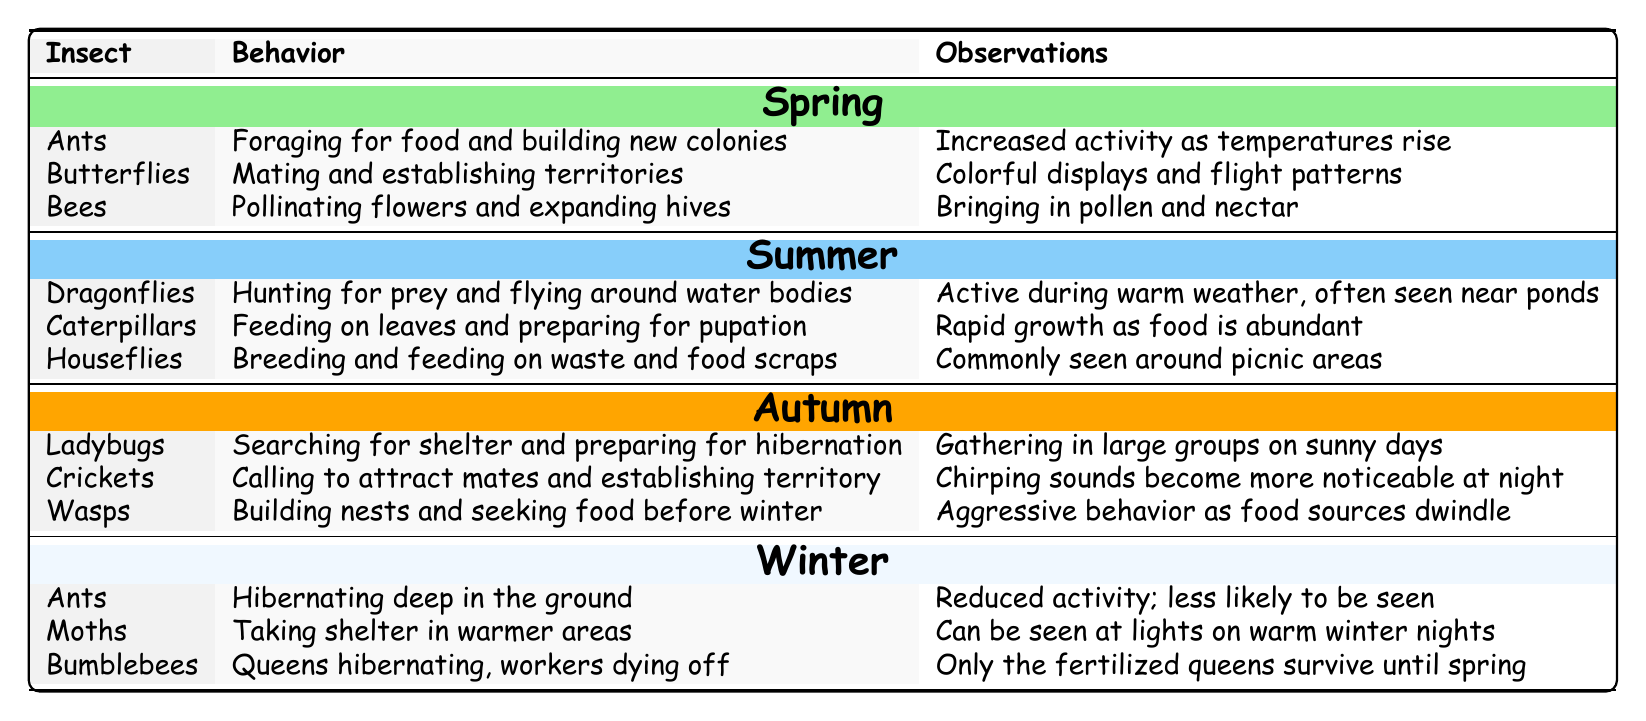What is the behavior of Ladybugs in Autumn? According to the table, Ladybugs are searching for shelter and preparing for hibernation during Autumn.
Answer: Searching for shelter and preparing for hibernation Which insects hibernate during Winter? The table lists ants, moths, and bumblebees as insects that hibernate during Winter.
Answer: Ants, moths, and bumblebees In which season are Dragonflies most active? The table indicates that Dragonflies are active during Summer, where they hunt for prey and frequently fly around water bodies.
Answer: Summer How many insects are listed for Spring? The table shows that there are three insects—Ants, Butterflies, and Bees—listed under Spring.
Answer: Three Do Caterpillars feed on leaves in Winter? The table does not mention Caterpillars in Winter; they are listed for Summer, indicating that they feed on leaves then.
Answer: No Which insect is known for aggressive behavior in Autumn? The table states that Wasps exhibit aggressive behavior in Autumn as they seek food before winter.
Answer: Wasps What is the observation related to Bees in Spring? The table notes that Bees bring in pollen and nectar to expand their hives during Spring.
Answer: Bringing in pollen and nectar Which insect behavior involves "chirping sounds"? Crickets are associated with chirping sounds to attract mates during Autumn according to the table.
Answer: Crickets What is the average number of insect behaviors observed per season? There are 12 behaviors total (3 for each of the 4 seasons). Dividing this by 4 seasons gives an average of 3 behaviors per season.
Answer: 3 Do all insects listed in Winter hibernate? While ants and bumblebees do hibernate, moths take shelter but are not specified to hibernate. Thus, the statement is false.
Answer: No 